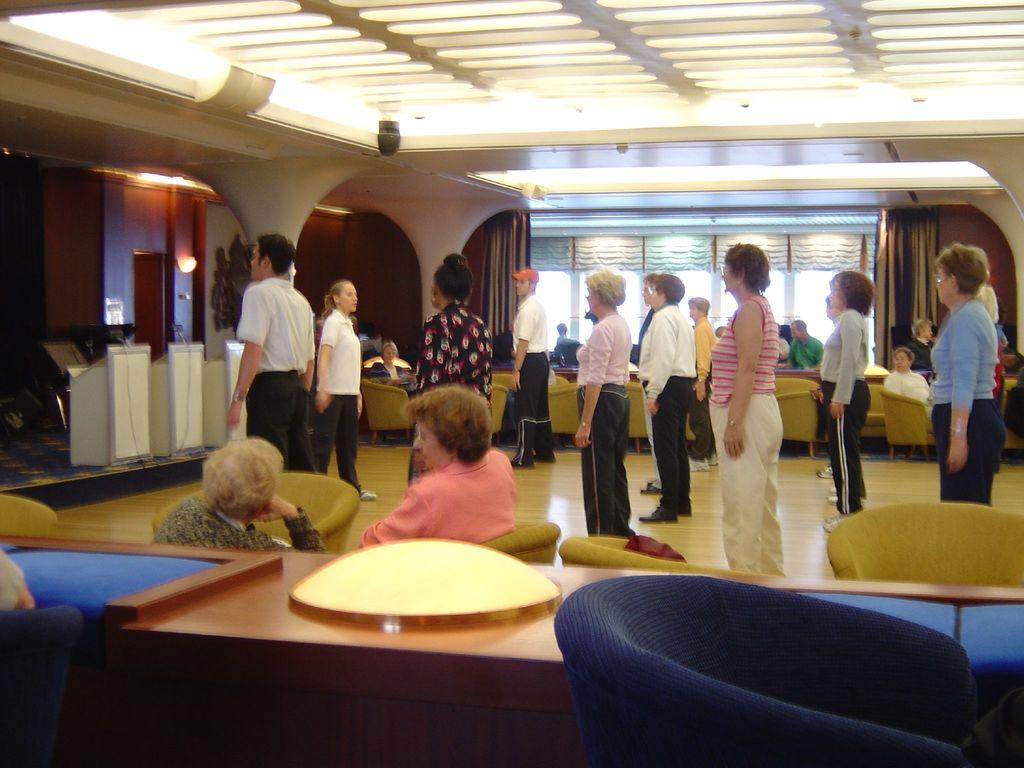What can be seen in the image involving people? There are people standing in the image. Where are the people standing? The people are standing on the floor. What object is present in the image that might be used for speeches or presentations? There is a podium in the image. What type of wall can be seen in the image? There is a wooden wall in the image. What type of furniture is present in the image? There are chairs in the image. What type of credit card is being used by the people in the image? There is no credit card visible in the image; it only shows people standing, a podium, a wooden wall, and chairs. 